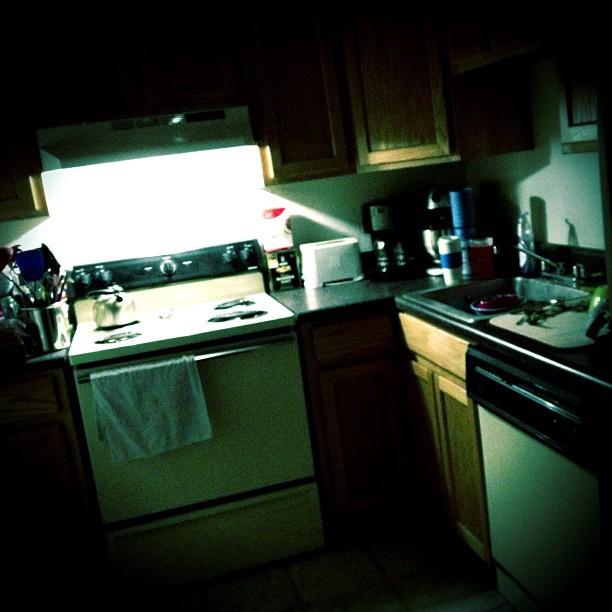Where is the towel hanging?
Concise answer only. Oven. Is this a brightly-lit kitchen?
Keep it brief. No. Is there any food in the oven?
Answer briefly. No. Is the countertop clean?
Be succinct. Yes. Is the light natural or not?
Answer briefly. No. 